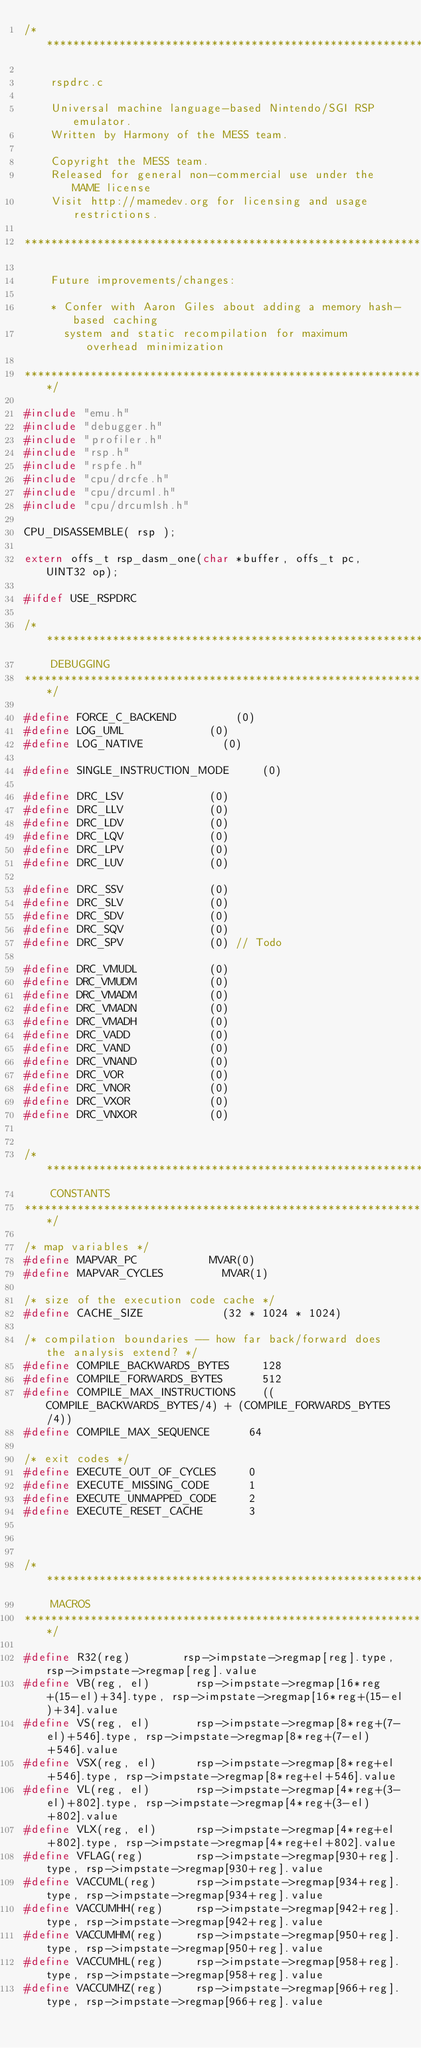<code> <loc_0><loc_0><loc_500><loc_500><_C_>/***************************************************************************

    rspdrc.c

    Universal machine language-based Nintendo/SGI RSP emulator.
    Written by Harmony of the MESS team.

    Copyright the MESS team.
    Released for general non-commercial use under the MAME license
    Visit http://mamedev.org for licensing and usage restrictions.

****************************************************************************

    Future improvements/changes:

    * Confer with Aaron Giles about adding a memory hash-based caching
      system and static recompilation for maximum overhead minimization

***************************************************************************/

#include "emu.h"
#include "debugger.h"
#include "profiler.h"
#include "rsp.h"
#include "rspfe.h"
#include "cpu/drcfe.h"
#include "cpu/drcuml.h"
#include "cpu/drcumlsh.h"

CPU_DISASSEMBLE( rsp );

extern offs_t rsp_dasm_one(char *buffer, offs_t pc, UINT32 op);

#ifdef USE_RSPDRC

/***************************************************************************
    DEBUGGING
***************************************************************************/

#define FORCE_C_BACKEND					(0)
#define LOG_UML							(0)
#define LOG_NATIVE						(0)

#define SINGLE_INSTRUCTION_MODE			(0)

#define DRC_LSV							(0)
#define DRC_LLV							(0)
#define DRC_LDV							(0)
#define DRC_LQV							(0)
#define DRC_LPV							(0)
#define DRC_LUV							(0)

#define DRC_SSV							(0)
#define DRC_SLV							(0)
#define DRC_SDV							(0)
#define DRC_SQV							(0)
#define DRC_SPV							(0) // Todo

#define DRC_VMUDL						(0)
#define DRC_VMUDM						(0)
#define DRC_VMADM						(0)
#define DRC_VMADN						(0)
#define DRC_VMADH						(0)
#define DRC_VADD						(0)
#define DRC_VAND						(0)
#define DRC_VNAND						(0)
#define DRC_VOR							(0)
#define DRC_VNOR						(0)
#define DRC_VXOR						(0)
#define DRC_VNXOR						(0)


/***************************************************************************
    CONSTANTS
***************************************************************************/

/* map variables */
#define MAPVAR_PC						MVAR(0)
#define MAPVAR_CYCLES					MVAR(1)

/* size of the execution code cache */
#define CACHE_SIZE						(32 * 1024 * 1024)

/* compilation boundaries -- how far back/forward does the analysis extend? */
#define COMPILE_BACKWARDS_BYTES			128
#define COMPILE_FORWARDS_BYTES			512
#define COMPILE_MAX_INSTRUCTIONS		((COMPILE_BACKWARDS_BYTES/4) + (COMPILE_FORWARDS_BYTES/4))
#define COMPILE_MAX_SEQUENCE			64

/* exit codes */
#define EXECUTE_OUT_OF_CYCLES			0
#define EXECUTE_MISSING_CODE			1
#define EXECUTE_UNMAPPED_CODE			2
#define EXECUTE_RESET_CACHE				3



/***************************************************************************
    MACROS
***************************************************************************/

#define R32(reg)				rsp->impstate->regmap[reg].type, rsp->impstate->regmap[reg].value
#define VB(reg, el)				rsp->impstate->regmap[16*reg+(15-el)+34].type, rsp->impstate->regmap[16*reg+(15-el)+34].value
#define VS(reg, el)				rsp->impstate->regmap[8*reg+(7-el)+546].type, rsp->impstate->regmap[8*reg+(7-el)+546].value
#define VSX(reg, el)			rsp->impstate->regmap[8*reg+el+546].type, rsp->impstate->regmap[8*reg+el+546].value
#define VL(reg, el)				rsp->impstate->regmap[4*reg+(3-el)+802].type, rsp->impstate->regmap[4*reg+(3-el)+802].value
#define VLX(reg, el)			rsp->impstate->regmap[4*reg+el+802].type, rsp->impstate->regmap[4*reg+el+802].value
#define VFLAG(reg)				rsp->impstate->regmap[930+reg].type, rsp->impstate->regmap[930+reg].value
#define VACCUML(reg)			rsp->impstate->regmap[934+reg].type, rsp->impstate->regmap[934+reg].value
#define VACCUMHH(reg)			rsp->impstate->regmap[942+reg].type, rsp->impstate->regmap[942+reg].value
#define VACCUMHM(reg)			rsp->impstate->regmap[950+reg].type, rsp->impstate->regmap[950+reg].value
#define VACCUMHL(reg)			rsp->impstate->regmap[958+reg].type, rsp->impstate->regmap[958+reg].value
#define VACCUMHZ(reg)			rsp->impstate->regmap[966+reg].type, rsp->impstate->regmap[966+reg].value</code> 